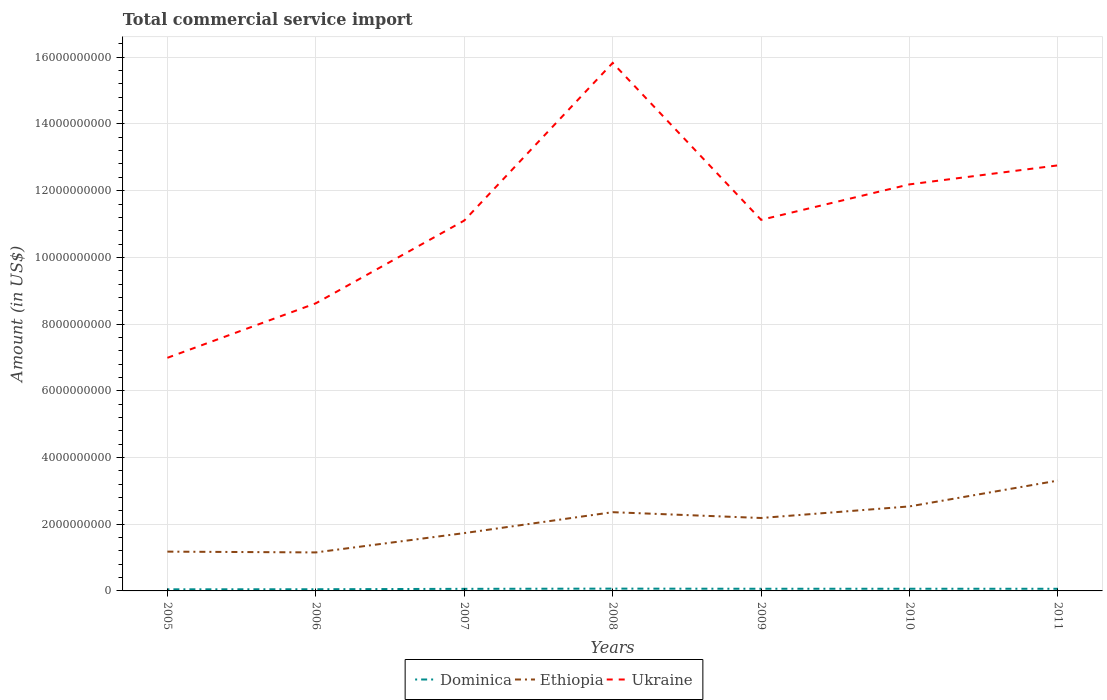Is the number of lines equal to the number of legend labels?
Offer a terse response. Yes. Across all years, what is the maximum total commercial service import in Ethiopia?
Give a very brief answer. 1.15e+09. In which year was the total commercial service import in Ukraine maximum?
Give a very brief answer. 2005. What is the total total commercial service import in Ethiopia in the graph?
Ensure brevity in your answer.  -5.55e+08. What is the difference between the highest and the second highest total commercial service import in Ethiopia?
Offer a very short reply. 2.15e+09. What is the difference between the highest and the lowest total commercial service import in Dominica?
Your answer should be compact. 5. Is the total commercial service import in Ethiopia strictly greater than the total commercial service import in Dominica over the years?
Give a very brief answer. No. What is the difference between two consecutive major ticks on the Y-axis?
Give a very brief answer. 2.00e+09. Are the values on the major ticks of Y-axis written in scientific E-notation?
Provide a short and direct response. No. Does the graph contain grids?
Make the answer very short. Yes. How are the legend labels stacked?
Provide a succinct answer. Horizontal. What is the title of the graph?
Keep it short and to the point. Total commercial service import. What is the label or title of the X-axis?
Keep it short and to the point. Years. What is the label or title of the Y-axis?
Provide a succinct answer. Amount (in US$). What is the Amount (in US$) in Dominica in 2005?
Offer a terse response. 4.81e+07. What is the Amount (in US$) in Ethiopia in 2005?
Ensure brevity in your answer.  1.18e+09. What is the Amount (in US$) of Ukraine in 2005?
Give a very brief answer. 6.99e+09. What is the Amount (in US$) in Dominica in 2006?
Keep it short and to the point. 5.03e+07. What is the Amount (in US$) in Ethiopia in 2006?
Make the answer very short. 1.15e+09. What is the Amount (in US$) in Ukraine in 2006?
Your answer should be very brief. 8.62e+09. What is the Amount (in US$) of Dominica in 2007?
Provide a succinct answer. 6.27e+07. What is the Amount (in US$) in Ethiopia in 2007?
Offer a terse response. 1.73e+09. What is the Amount (in US$) of Ukraine in 2007?
Offer a very short reply. 1.11e+1. What is the Amount (in US$) in Dominica in 2008?
Your response must be concise. 6.89e+07. What is the Amount (in US$) in Ethiopia in 2008?
Your response must be concise. 2.36e+09. What is the Amount (in US$) in Ukraine in 2008?
Provide a short and direct response. 1.58e+1. What is the Amount (in US$) of Dominica in 2009?
Provide a succinct answer. 6.50e+07. What is the Amount (in US$) in Ethiopia in 2009?
Keep it short and to the point. 2.19e+09. What is the Amount (in US$) in Ukraine in 2009?
Your response must be concise. 1.11e+1. What is the Amount (in US$) in Dominica in 2010?
Ensure brevity in your answer.  6.53e+07. What is the Amount (in US$) of Ethiopia in 2010?
Offer a terse response. 2.53e+09. What is the Amount (in US$) in Ukraine in 2010?
Your response must be concise. 1.22e+1. What is the Amount (in US$) in Dominica in 2011?
Provide a succinct answer. 6.43e+07. What is the Amount (in US$) in Ethiopia in 2011?
Make the answer very short. 3.31e+09. What is the Amount (in US$) of Ukraine in 2011?
Your answer should be very brief. 1.28e+1. Across all years, what is the maximum Amount (in US$) of Dominica?
Provide a succinct answer. 6.89e+07. Across all years, what is the maximum Amount (in US$) of Ethiopia?
Make the answer very short. 3.31e+09. Across all years, what is the maximum Amount (in US$) in Ukraine?
Give a very brief answer. 1.58e+1. Across all years, what is the minimum Amount (in US$) of Dominica?
Make the answer very short. 4.81e+07. Across all years, what is the minimum Amount (in US$) of Ethiopia?
Your response must be concise. 1.15e+09. Across all years, what is the minimum Amount (in US$) in Ukraine?
Offer a terse response. 6.99e+09. What is the total Amount (in US$) in Dominica in the graph?
Offer a very short reply. 4.25e+08. What is the total Amount (in US$) in Ethiopia in the graph?
Your answer should be compact. 1.45e+1. What is the total Amount (in US$) of Ukraine in the graph?
Your answer should be compact. 7.86e+1. What is the difference between the Amount (in US$) in Dominica in 2005 and that in 2006?
Give a very brief answer. -2.24e+06. What is the difference between the Amount (in US$) in Ethiopia in 2005 and that in 2006?
Provide a short and direct response. 2.38e+07. What is the difference between the Amount (in US$) in Ukraine in 2005 and that in 2006?
Provide a short and direct response. -1.63e+09. What is the difference between the Amount (in US$) in Dominica in 2005 and that in 2007?
Offer a terse response. -1.46e+07. What is the difference between the Amount (in US$) in Ethiopia in 2005 and that in 2007?
Make the answer very short. -5.55e+08. What is the difference between the Amount (in US$) in Ukraine in 2005 and that in 2007?
Your answer should be compact. -4.12e+09. What is the difference between the Amount (in US$) in Dominica in 2005 and that in 2008?
Your answer should be very brief. -2.08e+07. What is the difference between the Amount (in US$) of Ethiopia in 2005 and that in 2008?
Give a very brief answer. -1.18e+09. What is the difference between the Amount (in US$) of Ukraine in 2005 and that in 2008?
Ensure brevity in your answer.  -8.84e+09. What is the difference between the Amount (in US$) in Dominica in 2005 and that in 2009?
Ensure brevity in your answer.  -1.69e+07. What is the difference between the Amount (in US$) in Ethiopia in 2005 and that in 2009?
Your response must be concise. -1.01e+09. What is the difference between the Amount (in US$) in Ukraine in 2005 and that in 2009?
Your answer should be very brief. -4.14e+09. What is the difference between the Amount (in US$) of Dominica in 2005 and that in 2010?
Your response must be concise. -1.73e+07. What is the difference between the Amount (in US$) of Ethiopia in 2005 and that in 2010?
Ensure brevity in your answer.  -1.36e+09. What is the difference between the Amount (in US$) in Ukraine in 2005 and that in 2010?
Provide a short and direct response. -5.20e+09. What is the difference between the Amount (in US$) in Dominica in 2005 and that in 2011?
Your answer should be compact. -1.62e+07. What is the difference between the Amount (in US$) of Ethiopia in 2005 and that in 2011?
Make the answer very short. -2.13e+09. What is the difference between the Amount (in US$) of Ukraine in 2005 and that in 2011?
Your answer should be compact. -5.77e+09. What is the difference between the Amount (in US$) of Dominica in 2006 and that in 2007?
Provide a succinct answer. -1.23e+07. What is the difference between the Amount (in US$) of Ethiopia in 2006 and that in 2007?
Provide a succinct answer. -5.79e+08. What is the difference between the Amount (in US$) of Ukraine in 2006 and that in 2007?
Offer a very short reply. -2.48e+09. What is the difference between the Amount (in US$) of Dominica in 2006 and that in 2008?
Provide a short and direct response. -1.85e+07. What is the difference between the Amount (in US$) of Ethiopia in 2006 and that in 2008?
Provide a short and direct response. -1.21e+09. What is the difference between the Amount (in US$) of Ukraine in 2006 and that in 2008?
Give a very brief answer. -7.21e+09. What is the difference between the Amount (in US$) in Dominica in 2006 and that in 2009?
Your answer should be very brief. -1.46e+07. What is the difference between the Amount (in US$) in Ethiopia in 2006 and that in 2009?
Offer a very short reply. -1.03e+09. What is the difference between the Amount (in US$) of Ukraine in 2006 and that in 2009?
Offer a very short reply. -2.50e+09. What is the difference between the Amount (in US$) in Dominica in 2006 and that in 2010?
Your answer should be compact. -1.50e+07. What is the difference between the Amount (in US$) of Ethiopia in 2006 and that in 2010?
Provide a short and direct response. -1.38e+09. What is the difference between the Amount (in US$) in Ukraine in 2006 and that in 2010?
Your answer should be very brief. -3.57e+09. What is the difference between the Amount (in US$) of Dominica in 2006 and that in 2011?
Make the answer very short. -1.40e+07. What is the difference between the Amount (in US$) of Ethiopia in 2006 and that in 2011?
Offer a terse response. -2.15e+09. What is the difference between the Amount (in US$) of Ukraine in 2006 and that in 2011?
Provide a short and direct response. -4.14e+09. What is the difference between the Amount (in US$) of Dominica in 2007 and that in 2008?
Keep it short and to the point. -6.21e+06. What is the difference between the Amount (in US$) in Ethiopia in 2007 and that in 2008?
Offer a terse response. -6.27e+08. What is the difference between the Amount (in US$) of Ukraine in 2007 and that in 2008?
Your response must be concise. -4.73e+09. What is the difference between the Amount (in US$) of Dominica in 2007 and that in 2009?
Give a very brief answer. -2.32e+06. What is the difference between the Amount (in US$) of Ethiopia in 2007 and that in 2009?
Your answer should be very brief. -4.53e+08. What is the difference between the Amount (in US$) in Ukraine in 2007 and that in 2009?
Offer a very short reply. -2.10e+07. What is the difference between the Amount (in US$) of Dominica in 2007 and that in 2010?
Provide a short and direct response. -2.70e+06. What is the difference between the Amount (in US$) in Ethiopia in 2007 and that in 2010?
Provide a short and direct response. -8.00e+08. What is the difference between the Amount (in US$) in Ukraine in 2007 and that in 2010?
Offer a terse response. -1.08e+09. What is the difference between the Amount (in US$) of Dominica in 2007 and that in 2011?
Ensure brevity in your answer.  -1.68e+06. What is the difference between the Amount (in US$) in Ethiopia in 2007 and that in 2011?
Provide a short and direct response. -1.58e+09. What is the difference between the Amount (in US$) of Ukraine in 2007 and that in 2011?
Your answer should be very brief. -1.66e+09. What is the difference between the Amount (in US$) of Dominica in 2008 and that in 2009?
Provide a succinct answer. 3.88e+06. What is the difference between the Amount (in US$) of Ethiopia in 2008 and that in 2009?
Your response must be concise. 1.74e+08. What is the difference between the Amount (in US$) in Ukraine in 2008 and that in 2009?
Your response must be concise. 4.71e+09. What is the difference between the Amount (in US$) of Dominica in 2008 and that in 2010?
Your response must be concise. 3.51e+06. What is the difference between the Amount (in US$) in Ethiopia in 2008 and that in 2010?
Your answer should be compact. -1.73e+08. What is the difference between the Amount (in US$) in Ukraine in 2008 and that in 2010?
Offer a very short reply. 3.64e+09. What is the difference between the Amount (in US$) of Dominica in 2008 and that in 2011?
Provide a succinct answer. 4.52e+06. What is the difference between the Amount (in US$) in Ethiopia in 2008 and that in 2011?
Provide a succinct answer. -9.48e+08. What is the difference between the Amount (in US$) of Ukraine in 2008 and that in 2011?
Your response must be concise. 3.07e+09. What is the difference between the Amount (in US$) of Dominica in 2009 and that in 2010?
Provide a short and direct response. -3.77e+05. What is the difference between the Amount (in US$) in Ethiopia in 2009 and that in 2010?
Ensure brevity in your answer.  -3.47e+08. What is the difference between the Amount (in US$) in Ukraine in 2009 and that in 2010?
Keep it short and to the point. -1.06e+09. What is the difference between the Amount (in US$) in Dominica in 2009 and that in 2011?
Give a very brief answer. 6.38e+05. What is the difference between the Amount (in US$) of Ethiopia in 2009 and that in 2011?
Keep it short and to the point. -1.12e+09. What is the difference between the Amount (in US$) of Ukraine in 2009 and that in 2011?
Your answer should be very brief. -1.63e+09. What is the difference between the Amount (in US$) of Dominica in 2010 and that in 2011?
Offer a very short reply. 1.02e+06. What is the difference between the Amount (in US$) in Ethiopia in 2010 and that in 2011?
Your response must be concise. -7.75e+08. What is the difference between the Amount (in US$) in Ukraine in 2010 and that in 2011?
Your answer should be compact. -5.70e+08. What is the difference between the Amount (in US$) of Dominica in 2005 and the Amount (in US$) of Ethiopia in 2006?
Your response must be concise. -1.11e+09. What is the difference between the Amount (in US$) in Dominica in 2005 and the Amount (in US$) in Ukraine in 2006?
Ensure brevity in your answer.  -8.57e+09. What is the difference between the Amount (in US$) in Ethiopia in 2005 and the Amount (in US$) in Ukraine in 2006?
Make the answer very short. -7.44e+09. What is the difference between the Amount (in US$) in Dominica in 2005 and the Amount (in US$) in Ethiopia in 2007?
Offer a terse response. -1.69e+09. What is the difference between the Amount (in US$) of Dominica in 2005 and the Amount (in US$) of Ukraine in 2007?
Offer a very short reply. -1.11e+1. What is the difference between the Amount (in US$) of Ethiopia in 2005 and the Amount (in US$) of Ukraine in 2007?
Give a very brief answer. -9.93e+09. What is the difference between the Amount (in US$) of Dominica in 2005 and the Amount (in US$) of Ethiopia in 2008?
Provide a short and direct response. -2.31e+09. What is the difference between the Amount (in US$) in Dominica in 2005 and the Amount (in US$) in Ukraine in 2008?
Your answer should be compact. -1.58e+1. What is the difference between the Amount (in US$) in Ethiopia in 2005 and the Amount (in US$) in Ukraine in 2008?
Your answer should be compact. -1.47e+1. What is the difference between the Amount (in US$) of Dominica in 2005 and the Amount (in US$) of Ethiopia in 2009?
Make the answer very short. -2.14e+09. What is the difference between the Amount (in US$) in Dominica in 2005 and the Amount (in US$) in Ukraine in 2009?
Give a very brief answer. -1.11e+1. What is the difference between the Amount (in US$) of Ethiopia in 2005 and the Amount (in US$) of Ukraine in 2009?
Your answer should be compact. -9.95e+09. What is the difference between the Amount (in US$) in Dominica in 2005 and the Amount (in US$) in Ethiopia in 2010?
Provide a short and direct response. -2.49e+09. What is the difference between the Amount (in US$) of Dominica in 2005 and the Amount (in US$) of Ukraine in 2010?
Offer a terse response. -1.21e+1. What is the difference between the Amount (in US$) in Ethiopia in 2005 and the Amount (in US$) in Ukraine in 2010?
Offer a terse response. -1.10e+1. What is the difference between the Amount (in US$) in Dominica in 2005 and the Amount (in US$) in Ethiopia in 2011?
Keep it short and to the point. -3.26e+09. What is the difference between the Amount (in US$) of Dominica in 2005 and the Amount (in US$) of Ukraine in 2011?
Your answer should be compact. -1.27e+1. What is the difference between the Amount (in US$) in Ethiopia in 2005 and the Amount (in US$) in Ukraine in 2011?
Offer a very short reply. -1.16e+1. What is the difference between the Amount (in US$) in Dominica in 2006 and the Amount (in US$) in Ethiopia in 2007?
Ensure brevity in your answer.  -1.68e+09. What is the difference between the Amount (in US$) in Dominica in 2006 and the Amount (in US$) in Ukraine in 2007?
Offer a very short reply. -1.11e+1. What is the difference between the Amount (in US$) of Ethiopia in 2006 and the Amount (in US$) of Ukraine in 2007?
Offer a terse response. -9.95e+09. What is the difference between the Amount (in US$) in Dominica in 2006 and the Amount (in US$) in Ethiopia in 2008?
Provide a succinct answer. -2.31e+09. What is the difference between the Amount (in US$) in Dominica in 2006 and the Amount (in US$) in Ukraine in 2008?
Provide a succinct answer. -1.58e+1. What is the difference between the Amount (in US$) of Ethiopia in 2006 and the Amount (in US$) of Ukraine in 2008?
Offer a terse response. -1.47e+1. What is the difference between the Amount (in US$) of Dominica in 2006 and the Amount (in US$) of Ethiopia in 2009?
Offer a terse response. -2.14e+09. What is the difference between the Amount (in US$) of Dominica in 2006 and the Amount (in US$) of Ukraine in 2009?
Give a very brief answer. -1.11e+1. What is the difference between the Amount (in US$) of Ethiopia in 2006 and the Amount (in US$) of Ukraine in 2009?
Make the answer very short. -9.97e+09. What is the difference between the Amount (in US$) of Dominica in 2006 and the Amount (in US$) of Ethiopia in 2010?
Keep it short and to the point. -2.48e+09. What is the difference between the Amount (in US$) in Dominica in 2006 and the Amount (in US$) in Ukraine in 2010?
Provide a succinct answer. -1.21e+1. What is the difference between the Amount (in US$) in Ethiopia in 2006 and the Amount (in US$) in Ukraine in 2010?
Your answer should be very brief. -1.10e+1. What is the difference between the Amount (in US$) of Dominica in 2006 and the Amount (in US$) of Ethiopia in 2011?
Your answer should be very brief. -3.26e+09. What is the difference between the Amount (in US$) in Dominica in 2006 and the Amount (in US$) in Ukraine in 2011?
Make the answer very short. -1.27e+1. What is the difference between the Amount (in US$) of Ethiopia in 2006 and the Amount (in US$) of Ukraine in 2011?
Offer a very short reply. -1.16e+1. What is the difference between the Amount (in US$) in Dominica in 2007 and the Amount (in US$) in Ethiopia in 2008?
Keep it short and to the point. -2.30e+09. What is the difference between the Amount (in US$) of Dominica in 2007 and the Amount (in US$) of Ukraine in 2008?
Offer a very short reply. -1.58e+1. What is the difference between the Amount (in US$) of Ethiopia in 2007 and the Amount (in US$) of Ukraine in 2008?
Offer a terse response. -1.41e+1. What is the difference between the Amount (in US$) in Dominica in 2007 and the Amount (in US$) in Ethiopia in 2009?
Provide a succinct answer. -2.12e+09. What is the difference between the Amount (in US$) of Dominica in 2007 and the Amount (in US$) of Ukraine in 2009?
Your answer should be very brief. -1.11e+1. What is the difference between the Amount (in US$) of Ethiopia in 2007 and the Amount (in US$) of Ukraine in 2009?
Make the answer very short. -9.39e+09. What is the difference between the Amount (in US$) of Dominica in 2007 and the Amount (in US$) of Ethiopia in 2010?
Provide a succinct answer. -2.47e+09. What is the difference between the Amount (in US$) of Dominica in 2007 and the Amount (in US$) of Ukraine in 2010?
Your answer should be very brief. -1.21e+1. What is the difference between the Amount (in US$) of Ethiopia in 2007 and the Amount (in US$) of Ukraine in 2010?
Offer a terse response. -1.05e+1. What is the difference between the Amount (in US$) in Dominica in 2007 and the Amount (in US$) in Ethiopia in 2011?
Your answer should be very brief. -3.25e+09. What is the difference between the Amount (in US$) of Dominica in 2007 and the Amount (in US$) of Ukraine in 2011?
Your answer should be very brief. -1.27e+1. What is the difference between the Amount (in US$) of Ethiopia in 2007 and the Amount (in US$) of Ukraine in 2011?
Make the answer very short. -1.10e+1. What is the difference between the Amount (in US$) in Dominica in 2008 and the Amount (in US$) in Ethiopia in 2009?
Offer a terse response. -2.12e+09. What is the difference between the Amount (in US$) of Dominica in 2008 and the Amount (in US$) of Ukraine in 2009?
Offer a terse response. -1.11e+1. What is the difference between the Amount (in US$) in Ethiopia in 2008 and the Amount (in US$) in Ukraine in 2009?
Ensure brevity in your answer.  -8.76e+09. What is the difference between the Amount (in US$) in Dominica in 2008 and the Amount (in US$) in Ethiopia in 2010?
Your answer should be very brief. -2.46e+09. What is the difference between the Amount (in US$) in Dominica in 2008 and the Amount (in US$) in Ukraine in 2010?
Ensure brevity in your answer.  -1.21e+1. What is the difference between the Amount (in US$) of Ethiopia in 2008 and the Amount (in US$) of Ukraine in 2010?
Your answer should be compact. -9.83e+09. What is the difference between the Amount (in US$) in Dominica in 2008 and the Amount (in US$) in Ethiopia in 2011?
Provide a short and direct response. -3.24e+09. What is the difference between the Amount (in US$) in Dominica in 2008 and the Amount (in US$) in Ukraine in 2011?
Your response must be concise. -1.27e+1. What is the difference between the Amount (in US$) of Ethiopia in 2008 and the Amount (in US$) of Ukraine in 2011?
Provide a short and direct response. -1.04e+1. What is the difference between the Amount (in US$) of Dominica in 2009 and the Amount (in US$) of Ethiopia in 2010?
Give a very brief answer. -2.47e+09. What is the difference between the Amount (in US$) of Dominica in 2009 and the Amount (in US$) of Ukraine in 2010?
Your response must be concise. -1.21e+1. What is the difference between the Amount (in US$) in Ethiopia in 2009 and the Amount (in US$) in Ukraine in 2010?
Give a very brief answer. -1.00e+1. What is the difference between the Amount (in US$) of Dominica in 2009 and the Amount (in US$) of Ethiopia in 2011?
Give a very brief answer. -3.24e+09. What is the difference between the Amount (in US$) of Dominica in 2009 and the Amount (in US$) of Ukraine in 2011?
Make the answer very short. -1.27e+1. What is the difference between the Amount (in US$) in Ethiopia in 2009 and the Amount (in US$) in Ukraine in 2011?
Offer a terse response. -1.06e+1. What is the difference between the Amount (in US$) in Dominica in 2010 and the Amount (in US$) in Ethiopia in 2011?
Your answer should be very brief. -3.24e+09. What is the difference between the Amount (in US$) in Dominica in 2010 and the Amount (in US$) in Ukraine in 2011?
Make the answer very short. -1.27e+1. What is the difference between the Amount (in US$) in Ethiopia in 2010 and the Amount (in US$) in Ukraine in 2011?
Ensure brevity in your answer.  -1.02e+1. What is the average Amount (in US$) in Dominica per year?
Your answer should be very brief. 6.07e+07. What is the average Amount (in US$) in Ethiopia per year?
Provide a short and direct response. 2.07e+09. What is the average Amount (in US$) of Ukraine per year?
Make the answer very short. 1.12e+1. In the year 2005, what is the difference between the Amount (in US$) of Dominica and Amount (in US$) of Ethiopia?
Your response must be concise. -1.13e+09. In the year 2005, what is the difference between the Amount (in US$) of Dominica and Amount (in US$) of Ukraine?
Offer a terse response. -6.94e+09. In the year 2005, what is the difference between the Amount (in US$) of Ethiopia and Amount (in US$) of Ukraine?
Offer a very short reply. -5.81e+09. In the year 2006, what is the difference between the Amount (in US$) in Dominica and Amount (in US$) in Ethiopia?
Ensure brevity in your answer.  -1.10e+09. In the year 2006, what is the difference between the Amount (in US$) of Dominica and Amount (in US$) of Ukraine?
Give a very brief answer. -8.57e+09. In the year 2006, what is the difference between the Amount (in US$) in Ethiopia and Amount (in US$) in Ukraine?
Make the answer very short. -7.47e+09. In the year 2007, what is the difference between the Amount (in US$) of Dominica and Amount (in US$) of Ethiopia?
Give a very brief answer. -1.67e+09. In the year 2007, what is the difference between the Amount (in US$) of Dominica and Amount (in US$) of Ukraine?
Provide a short and direct response. -1.10e+1. In the year 2007, what is the difference between the Amount (in US$) of Ethiopia and Amount (in US$) of Ukraine?
Provide a succinct answer. -9.37e+09. In the year 2008, what is the difference between the Amount (in US$) of Dominica and Amount (in US$) of Ethiopia?
Give a very brief answer. -2.29e+09. In the year 2008, what is the difference between the Amount (in US$) in Dominica and Amount (in US$) in Ukraine?
Offer a terse response. -1.58e+1. In the year 2008, what is the difference between the Amount (in US$) in Ethiopia and Amount (in US$) in Ukraine?
Ensure brevity in your answer.  -1.35e+1. In the year 2009, what is the difference between the Amount (in US$) in Dominica and Amount (in US$) in Ethiopia?
Your response must be concise. -2.12e+09. In the year 2009, what is the difference between the Amount (in US$) of Dominica and Amount (in US$) of Ukraine?
Give a very brief answer. -1.11e+1. In the year 2009, what is the difference between the Amount (in US$) of Ethiopia and Amount (in US$) of Ukraine?
Provide a short and direct response. -8.94e+09. In the year 2010, what is the difference between the Amount (in US$) of Dominica and Amount (in US$) of Ethiopia?
Make the answer very short. -2.47e+09. In the year 2010, what is the difference between the Amount (in US$) of Dominica and Amount (in US$) of Ukraine?
Offer a very short reply. -1.21e+1. In the year 2010, what is the difference between the Amount (in US$) in Ethiopia and Amount (in US$) in Ukraine?
Provide a succinct answer. -9.66e+09. In the year 2011, what is the difference between the Amount (in US$) in Dominica and Amount (in US$) in Ethiopia?
Ensure brevity in your answer.  -3.24e+09. In the year 2011, what is the difference between the Amount (in US$) of Dominica and Amount (in US$) of Ukraine?
Your answer should be very brief. -1.27e+1. In the year 2011, what is the difference between the Amount (in US$) in Ethiopia and Amount (in US$) in Ukraine?
Provide a succinct answer. -9.45e+09. What is the ratio of the Amount (in US$) in Dominica in 2005 to that in 2006?
Make the answer very short. 0.96. What is the ratio of the Amount (in US$) in Ethiopia in 2005 to that in 2006?
Make the answer very short. 1.02. What is the ratio of the Amount (in US$) in Ukraine in 2005 to that in 2006?
Offer a terse response. 0.81. What is the ratio of the Amount (in US$) of Dominica in 2005 to that in 2007?
Your answer should be very brief. 0.77. What is the ratio of the Amount (in US$) in Ethiopia in 2005 to that in 2007?
Offer a very short reply. 0.68. What is the ratio of the Amount (in US$) of Ukraine in 2005 to that in 2007?
Give a very brief answer. 0.63. What is the ratio of the Amount (in US$) of Dominica in 2005 to that in 2008?
Keep it short and to the point. 0.7. What is the ratio of the Amount (in US$) in Ethiopia in 2005 to that in 2008?
Give a very brief answer. 0.5. What is the ratio of the Amount (in US$) of Ukraine in 2005 to that in 2008?
Offer a terse response. 0.44. What is the ratio of the Amount (in US$) of Dominica in 2005 to that in 2009?
Your answer should be compact. 0.74. What is the ratio of the Amount (in US$) of Ethiopia in 2005 to that in 2009?
Your answer should be compact. 0.54. What is the ratio of the Amount (in US$) in Ukraine in 2005 to that in 2009?
Provide a short and direct response. 0.63. What is the ratio of the Amount (in US$) of Dominica in 2005 to that in 2010?
Offer a terse response. 0.74. What is the ratio of the Amount (in US$) in Ethiopia in 2005 to that in 2010?
Give a very brief answer. 0.46. What is the ratio of the Amount (in US$) in Ukraine in 2005 to that in 2010?
Provide a succinct answer. 0.57. What is the ratio of the Amount (in US$) of Dominica in 2005 to that in 2011?
Provide a succinct answer. 0.75. What is the ratio of the Amount (in US$) of Ethiopia in 2005 to that in 2011?
Offer a very short reply. 0.36. What is the ratio of the Amount (in US$) of Ukraine in 2005 to that in 2011?
Your answer should be compact. 0.55. What is the ratio of the Amount (in US$) of Dominica in 2006 to that in 2007?
Offer a terse response. 0.8. What is the ratio of the Amount (in US$) in Ethiopia in 2006 to that in 2007?
Provide a short and direct response. 0.67. What is the ratio of the Amount (in US$) of Ukraine in 2006 to that in 2007?
Provide a succinct answer. 0.78. What is the ratio of the Amount (in US$) of Dominica in 2006 to that in 2008?
Offer a terse response. 0.73. What is the ratio of the Amount (in US$) in Ethiopia in 2006 to that in 2008?
Offer a very short reply. 0.49. What is the ratio of the Amount (in US$) of Ukraine in 2006 to that in 2008?
Provide a succinct answer. 0.54. What is the ratio of the Amount (in US$) of Dominica in 2006 to that in 2009?
Offer a very short reply. 0.77. What is the ratio of the Amount (in US$) in Ethiopia in 2006 to that in 2009?
Ensure brevity in your answer.  0.53. What is the ratio of the Amount (in US$) of Ukraine in 2006 to that in 2009?
Keep it short and to the point. 0.78. What is the ratio of the Amount (in US$) of Dominica in 2006 to that in 2010?
Your response must be concise. 0.77. What is the ratio of the Amount (in US$) in Ethiopia in 2006 to that in 2010?
Offer a terse response. 0.46. What is the ratio of the Amount (in US$) of Ukraine in 2006 to that in 2010?
Your response must be concise. 0.71. What is the ratio of the Amount (in US$) of Dominica in 2006 to that in 2011?
Make the answer very short. 0.78. What is the ratio of the Amount (in US$) of Ethiopia in 2006 to that in 2011?
Make the answer very short. 0.35. What is the ratio of the Amount (in US$) in Ukraine in 2006 to that in 2011?
Offer a terse response. 0.68. What is the ratio of the Amount (in US$) of Dominica in 2007 to that in 2008?
Your response must be concise. 0.91. What is the ratio of the Amount (in US$) of Ethiopia in 2007 to that in 2008?
Provide a succinct answer. 0.73. What is the ratio of the Amount (in US$) of Ukraine in 2007 to that in 2008?
Ensure brevity in your answer.  0.7. What is the ratio of the Amount (in US$) in Ethiopia in 2007 to that in 2009?
Make the answer very short. 0.79. What is the ratio of the Amount (in US$) of Ukraine in 2007 to that in 2009?
Provide a short and direct response. 1. What is the ratio of the Amount (in US$) of Dominica in 2007 to that in 2010?
Your response must be concise. 0.96. What is the ratio of the Amount (in US$) of Ethiopia in 2007 to that in 2010?
Provide a succinct answer. 0.68. What is the ratio of the Amount (in US$) of Ukraine in 2007 to that in 2010?
Offer a terse response. 0.91. What is the ratio of the Amount (in US$) of Dominica in 2007 to that in 2011?
Your response must be concise. 0.97. What is the ratio of the Amount (in US$) of Ethiopia in 2007 to that in 2011?
Your answer should be very brief. 0.52. What is the ratio of the Amount (in US$) in Ukraine in 2007 to that in 2011?
Ensure brevity in your answer.  0.87. What is the ratio of the Amount (in US$) of Dominica in 2008 to that in 2009?
Provide a succinct answer. 1.06. What is the ratio of the Amount (in US$) in Ethiopia in 2008 to that in 2009?
Offer a terse response. 1.08. What is the ratio of the Amount (in US$) in Ukraine in 2008 to that in 2009?
Your answer should be very brief. 1.42. What is the ratio of the Amount (in US$) in Dominica in 2008 to that in 2010?
Offer a very short reply. 1.05. What is the ratio of the Amount (in US$) in Ethiopia in 2008 to that in 2010?
Offer a very short reply. 0.93. What is the ratio of the Amount (in US$) in Ukraine in 2008 to that in 2010?
Give a very brief answer. 1.3. What is the ratio of the Amount (in US$) in Dominica in 2008 to that in 2011?
Provide a succinct answer. 1.07. What is the ratio of the Amount (in US$) of Ethiopia in 2008 to that in 2011?
Your response must be concise. 0.71. What is the ratio of the Amount (in US$) of Ukraine in 2008 to that in 2011?
Provide a succinct answer. 1.24. What is the ratio of the Amount (in US$) of Dominica in 2009 to that in 2010?
Your response must be concise. 0.99. What is the ratio of the Amount (in US$) of Ethiopia in 2009 to that in 2010?
Your answer should be compact. 0.86. What is the ratio of the Amount (in US$) in Ukraine in 2009 to that in 2010?
Your answer should be very brief. 0.91. What is the ratio of the Amount (in US$) of Dominica in 2009 to that in 2011?
Make the answer very short. 1.01. What is the ratio of the Amount (in US$) of Ethiopia in 2009 to that in 2011?
Make the answer very short. 0.66. What is the ratio of the Amount (in US$) in Ukraine in 2009 to that in 2011?
Provide a succinct answer. 0.87. What is the ratio of the Amount (in US$) of Dominica in 2010 to that in 2011?
Your response must be concise. 1.02. What is the ratio of the Amount (in US$) in Ethiopia in 2010 to that in 2011?
Give a very brief answer. 0.77. What is the ratio of the Amount (in US$) of Ukraine in 2010 to that in 2011?
Give a very brief answer. 0.96. What is the difference between the highest and the second highest Amount (in US$) of Dominica?
Offer a very short reply. 3.51e+06. What is the difference between the highest and the second highest Amount (in US$) in Ethiopia?
Your answer should be compact. 7.75e+08. What is the difference between the highest and the second highest Amount (in US$) in Ukraine?
Make the answer very short. 3.07e+09. What is the difference between the highest and the lowest Amount (in US$) in Dominica?
Offer a terse response. 2.08e+07. What is the difference between the highest and the lowest Amount (in US$) of Ethiopia?
Give a very brief answer. 2.15e+09. What is the difference between the highest and the lowest Amount (in US$) in Ukraine?
Make the answer very short. 8.84e+09. 